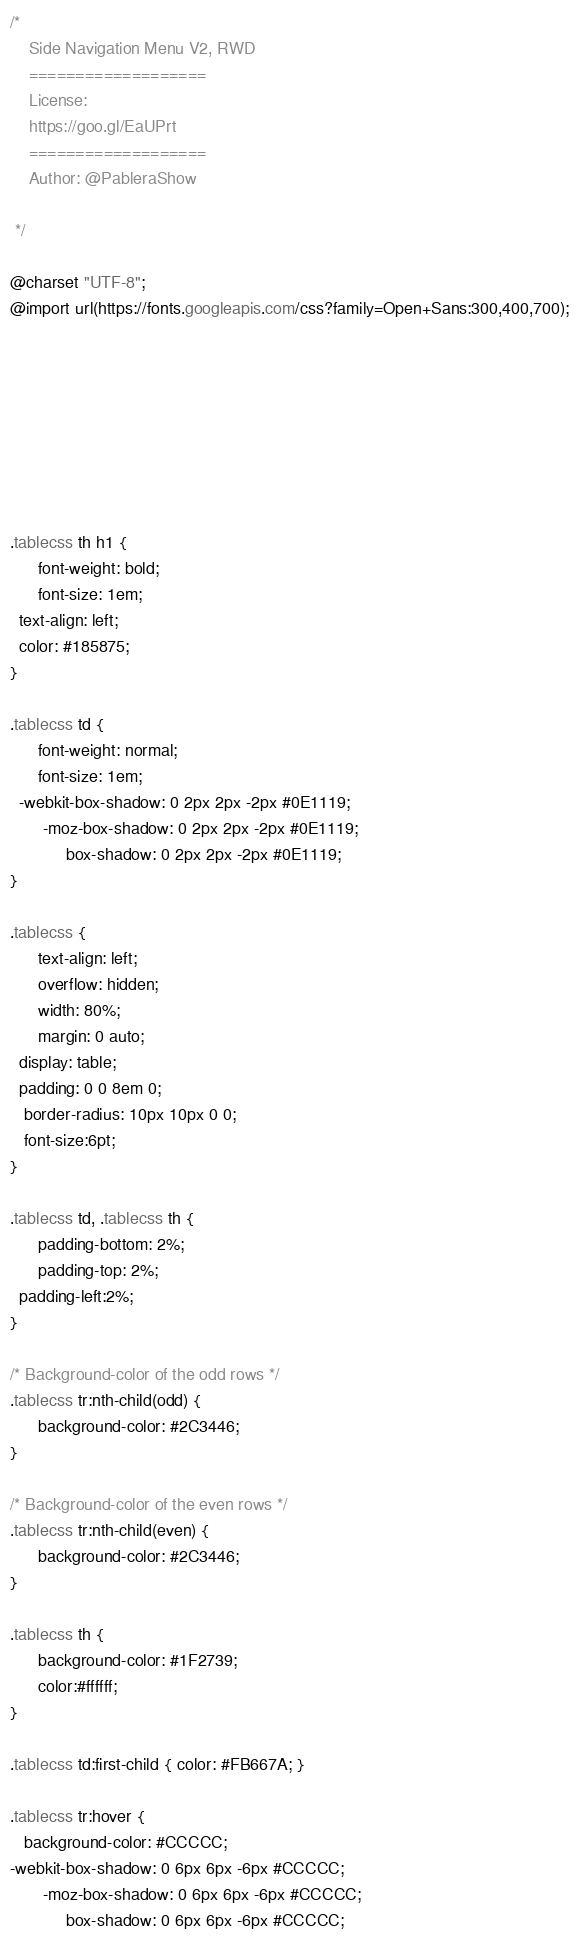Convert code to text. <code><loc_0><loc_0><loc_500><loc_500><_CSS_>/*	
	Side Navigation Menu V2, RWD
	===================
	License:
	https://goo.gl/EaUPrt
	===================
	Author: @PableraShow

 */

@charset "UTF-8";
@import url(https://fonts.googleapis.com/css?family=Open+Sans:300,400,700);








.tablecss th h1 {
	  font-weight: bold;
	  font-size: 1em;
  text-align: left;
  color: #185875;
}

.tablecss td {
	  font-weight: normal;
	  font-size: 1em;
  -webkit-box-shadow: 0 2px 2px -2px #0E1119;
	   -moz-box-shadow: 0 2px 2px -2px #0E1119;
	        box-shadow: 0 2px 2px -2px #0E1119;
}

.tablecss {
	  text-align: left;
	  overflow: hidden;
	  width: 80%;
	  margin: 0 auto;
  display: table;
  padding: 0 0 8em 0;
   border-radius: 10px 10px 0 0;
   font-size:6pt;
}

.tablecss td, .tablecss th {
	  padding-bottom: 2%;
	  padding-top: 2%;
  padding-left:2%;  
}

/* Background-color of the odd rows */
.tablecss tr:nth-child(odd) {
	  background-color: #2C3446;
}

/* Background-color of the even rows */
.tablecss tr:nth-child(even) {
	  background-color: #2C3446;
}

.tablecss th {
	  background-color: #1F2739;
	  color:#ffffff;
}

.tablecss td:first-child { color: #FB667A; }

.tablecss tr:hover {
   background-color: #CCCCC;
-webkit-box-shadow: 0 6px 6px -6px #CCCCC;
	   -moz-box-shadow: 0 6px 6px -6px #CCCCC;
	        box-shadow: 0 6px 6px -6px #CCCCC;</code> 